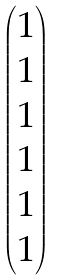<formula> <loc_0><loc_0><loc_500><loc_500>\begin{pmatrix} 1 \\ 1 \\ 1 \\ 1 \\ 1 \\ 1 \end{pmatrix}</formula> 